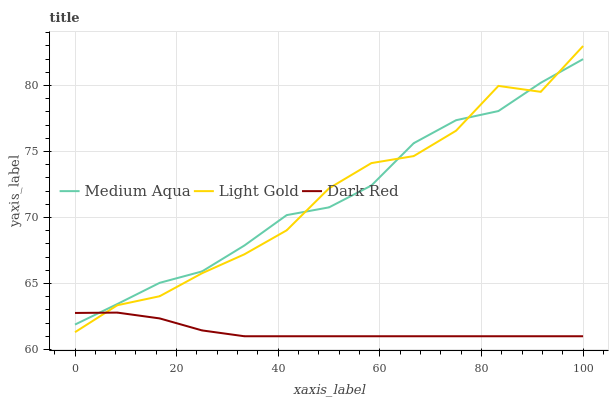Does Dark Red have the minimum area under the curve?
Answer yes or no. Yes. Does Medium Aqua have the maximum area under the curve?
Answer yes or no. Yes. Does Medium Aqua have the minimum area under the curve?
Answer yes or no. No. Does Dark Red have the maximum area under the curve?
Answer yes or no. No. Is Dark Red the smoothest?
Answer yes or no. Yes. Is Light Gold the roughest?
Answer yes or no. Yes. Is Medium Aqua the smoothest?
Answer yes or no. No. Is Medium Aqua the roughest?
Answer yes or no. No. Does Dark Red have the lowest value?
Answer yes or no. Yes. Does Medium Aqua have the lowest value?
Answer yes or no. No. Does Light Gold have the highest value?
Answer yes or no. Yes. Does Medium Aqua have the highest value?
Answer yes or no. No. Does Light Gold intersect Dark Red?
Answer yes or no. Yes. Is Light Gold less than Dark Red?
Answer yes or no. No. Is Light Gold greater than Dark Red?
Answer yes or no. No. 